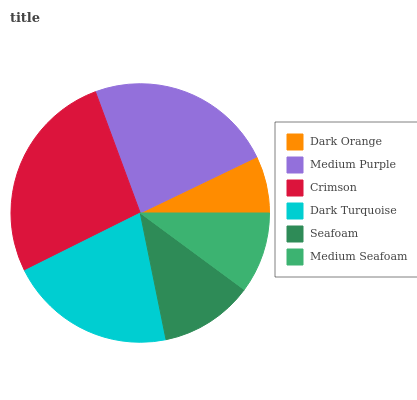Is Dark Orange the minimum?
Answer yes or no. Yes. Is Crimson the maximum?
Answer yes or no. Yes. Is Medium Purple the minimum?
Answer yes or no. No. Is Medium Purple the maximum?
Answer yes or no. No. Is Medium Purple greater than Dark Orange?
Answer yes or no. Yes. Is Dark Orange less than Medium Purple?
Answer yes or no. Yes. Is Dark Orange greater than Medium Purple?
Answer yes or no. No. Is Medium Purple less than Dark Orange?
Answer yes or no. No. Is Dark Turquoise the high median?
Answer yes or no. Yes. Is Seafoam the low median?
Answer yes or no. Yes. Is Seafoam the high median?
Answer yes or no. No. Is Medium Purple the low median?
Answer yes or no. No. 